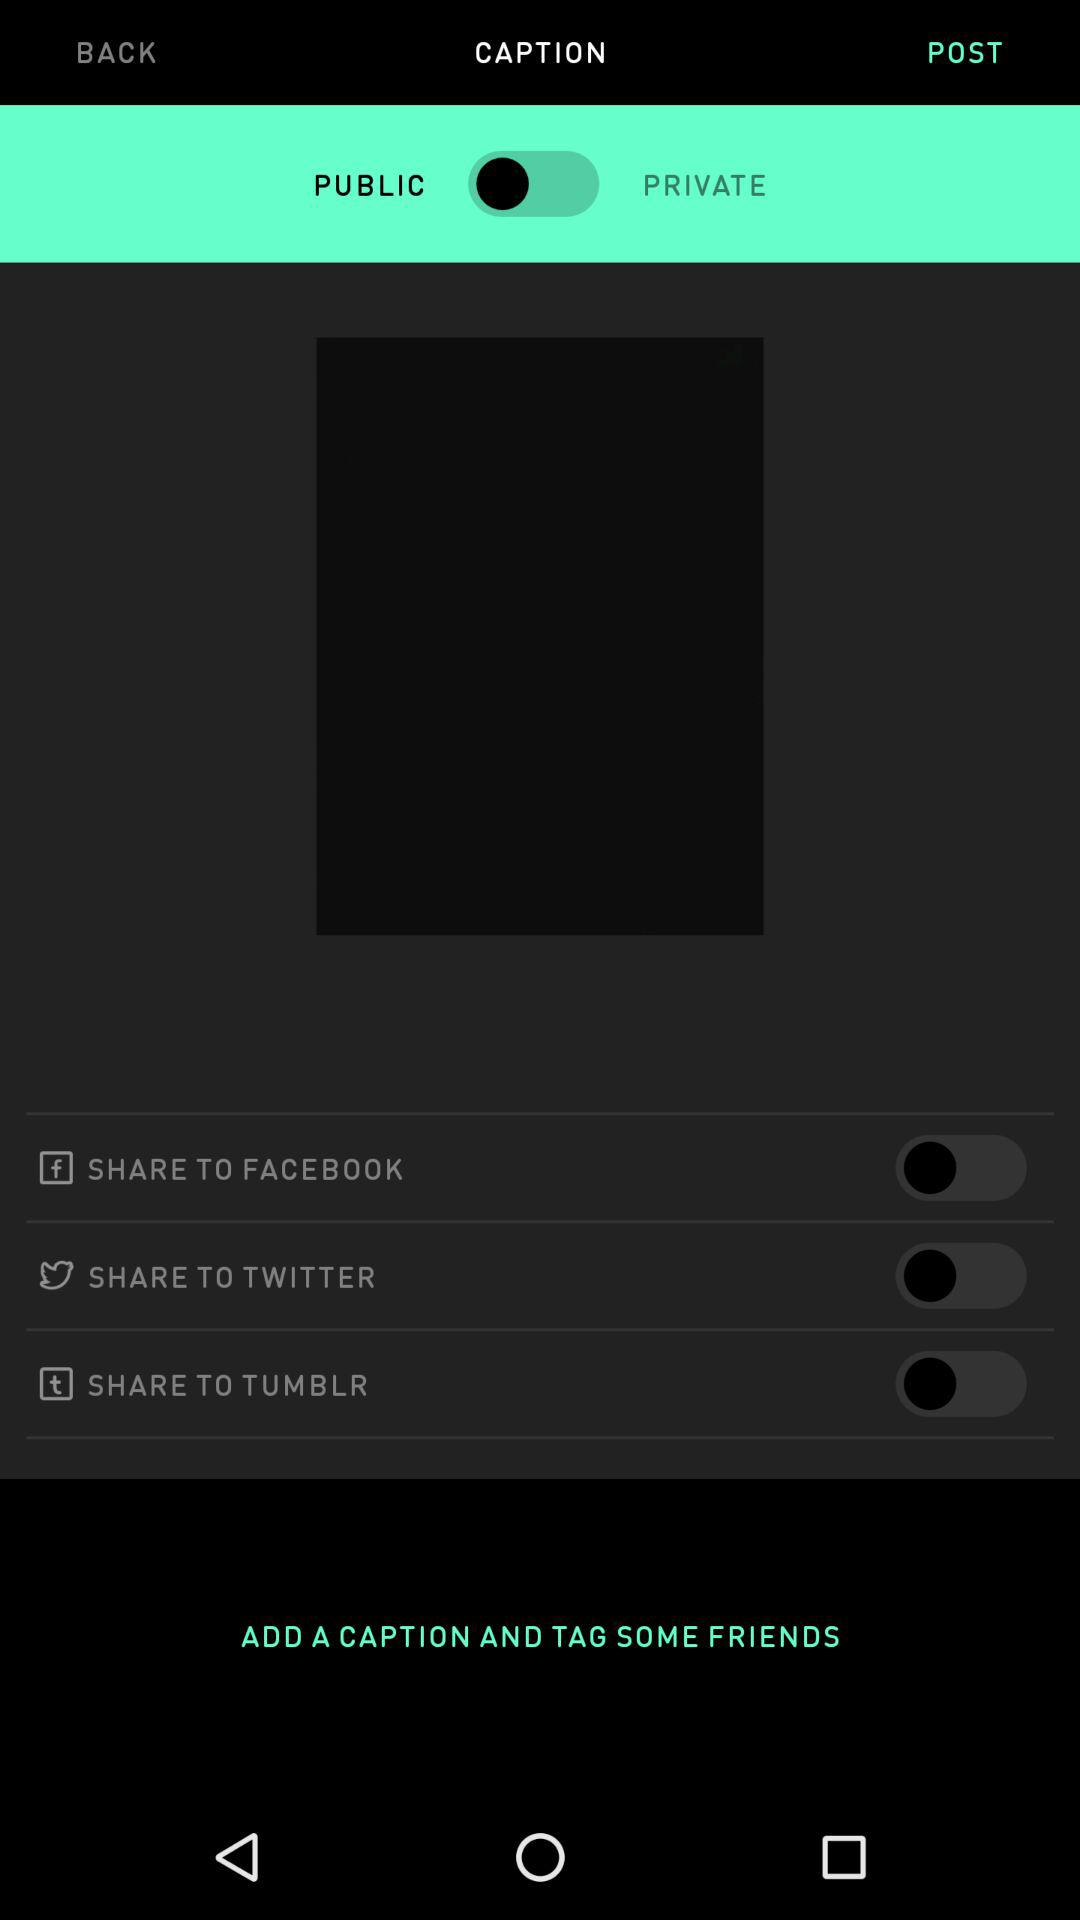How many more share options are there than privacy options?
Answer the question using a single word or phrase. 2 